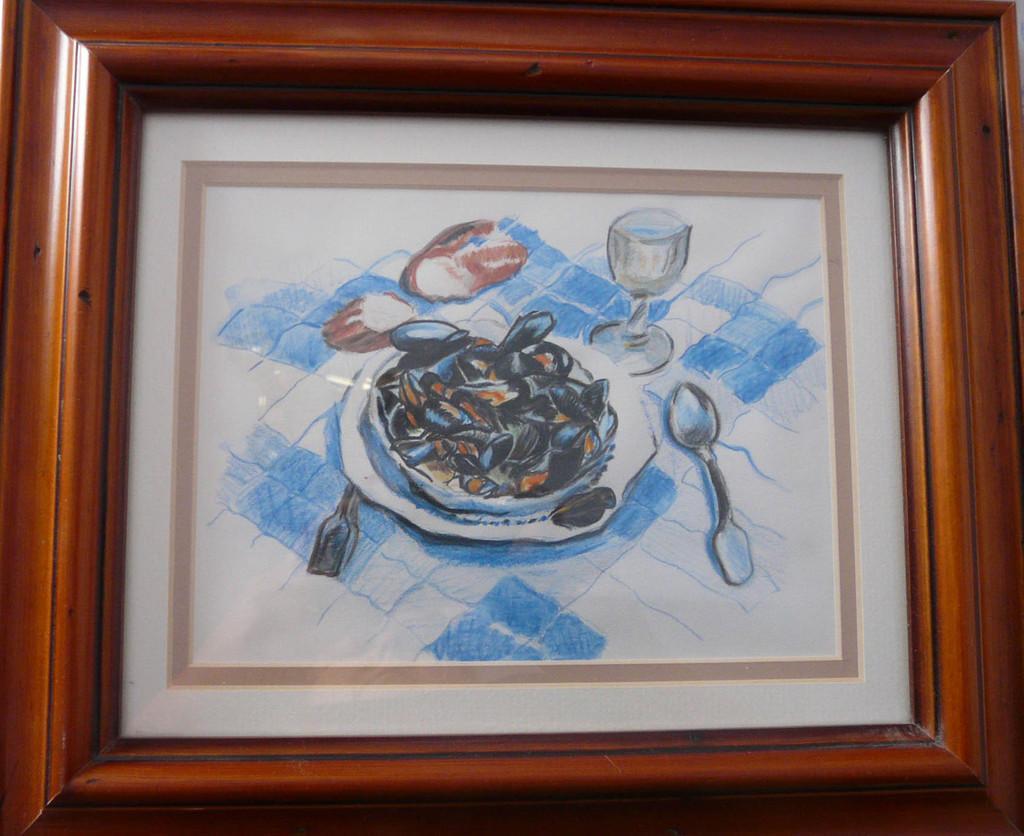Can you describe this image briefly? In the image we can see a frame and in it there is a picture of a wine glass, spoon, plate and a food on a plate. 